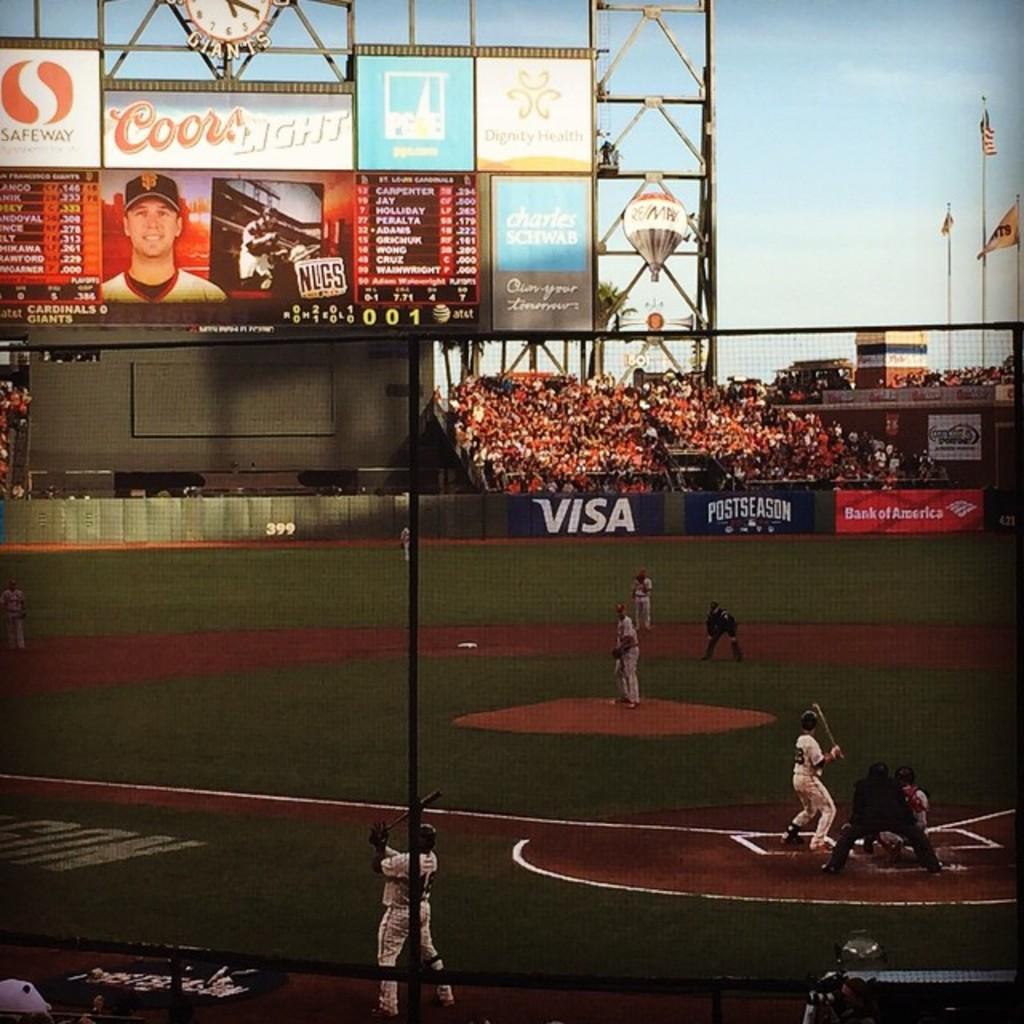What companies sponsor this event?
Make the answer very short. Visa, bank of america, safeway, coors light, charles schwab. What beer company is above the board?
Offer a very short reply. Coors light. 